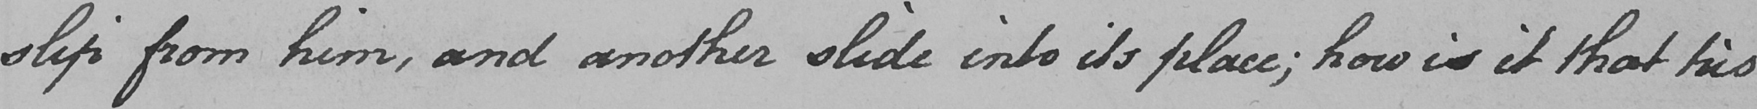What text is written in this handwritten line? slip from him , and another slide into its place ; how is it that his 